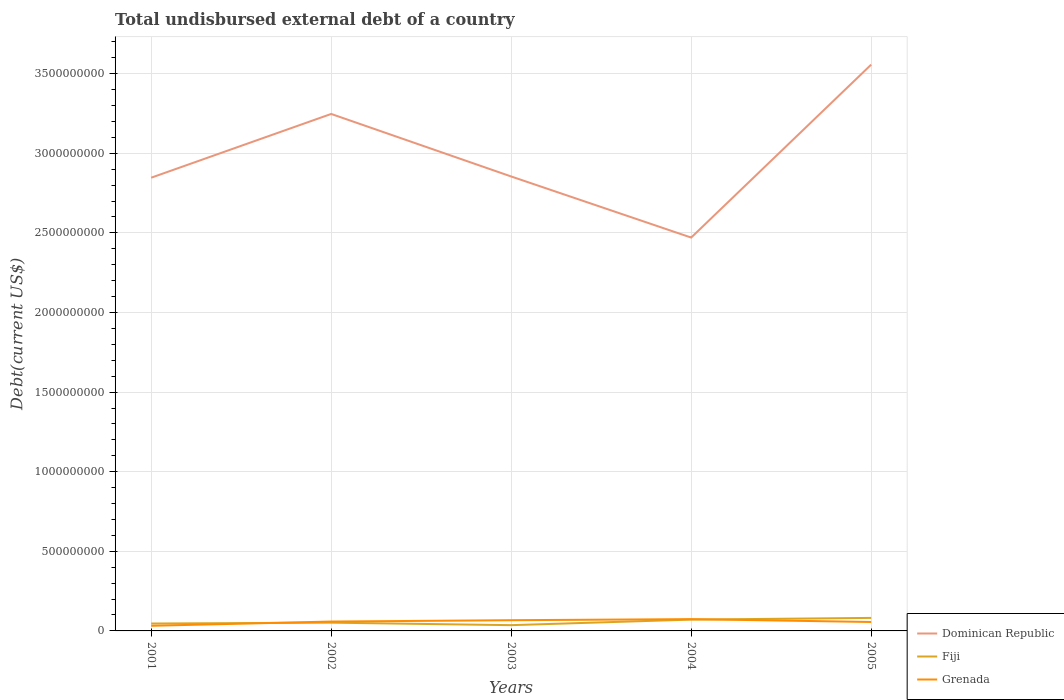Does the line corresponding to Grenada intersect with the line corresponding to Dominican Republic?
Your answer should be very brief. No. Is the number of lines equal to the number of legend labels?
Keep it short and to the point. Yes. Across all years, what is the maximum total undisbursed external debt in Dominican Republic?
Your response must be concise. 2.47e+09. What is the total total undisbursed external debt in Grenada in the graph?
Your answer should be very brief. -6.70e+06. What is the difference between the highest and the second highest total undisbursed external debt in Fiji?
Keep it short and to the point. 4.55e+07. What is the difference between the highest and the lowest total undisbursed external debt in Fiji?
Ensure brevity in your answer.  2. Is the total undisbursed external debt in Grenada strictly greater than the total undisbursed external debt in Fiji over the years?
Offer a very short reply. No. How many lines are there?
Ensure brevity in your answer.  3. Does the graph contain grids?
Provide a succinct answer. Yes. Where does the legend appear in the graph?
Your answer should be compact. Bottom right. What is the title of the graph?
Your response must be concise. Total undisbursed external debt of a country. What is the label or title of the X-axis?
Offer a very short reply. Years. What is the label or title of the Y-axis?
Offer a very short reply. Debt(current US$). What is the Debt(current US$) of Dominican Republic in 2001?
Provide a short and direct response. 2.85e+09. What is the Debt(current US$) of Fiji in 2001?
Offer a terse response. 4.64e+07. What is the Debt(current US$) in Grenada in 2001?
Your answer should be very brief. 3.23e+07. What is the Debt(current US$) in Dominican Republic in 2002?
Your response must be concise. 3.25e+09. What is the Debt(current US$) in Fiji in 2002?
Provide a succinct answer. 5.19e+07. What is the Debt(current US$) of Grenada in 2002?
Your answer should be very brief. 5.88e+07. What is the Debt(current US$) in Dominican Republic in 2003?
Your answer should be very brief. 2.85e+09. What is the Debt(current US$) in Fiji in 2003?
Provide a short and direct response. 3.62e+07. What is the Debt(current US$) in Grenada in 2003?
Your response must be concise. 6.73e+07. What is the Debt(current US$) in Dominican Republic in 2004?
Ensure brevity in your answer.  2.47e+09. What is the Debt(current US$) of Fiji in 2004?
Provide a succinct answer. 7.10e+07. What is the Debt(current US$) in Grenada in 2004?
Offer a very short reply. 7.40e+07. What is the Debt(current US$) of Dominican Republic in 2005?
Make the answer very short. 3.56e+09. What is the Debt(current US$) of Fiji in 2005?
Your answer should be compact. 8.17e+07. What is the Debt(current US$) of Grenada in 2005?
Your answer should be compact. 5.61e+07. Across all years, what is the maximum Debt(current US$) in Dominican Republic?
Provide a short and direct response. 3.56e+09. Across all years, what is the maximum Debt(current US$) in Fiji?
Your answer should be compact. 8.17e+07. Across all years, what is the maximum Debt(current US$) of Grenada?
Provide a succinct answer. 7.40e+07. Across all years, what is the minimum Debt(current US$) in Dominican Republic?
Provide a short and direct response. 2.47e+09. Across all years, what is the minimum Debt(current US$) in Fiji?
Your answer should be very brief. 3.62e+07. Across all years, what is the minimum Debt(current US$) of Grenada?
Your answer should be compact. 3.23e+07. What is the total Debt(current US$) in Dominican Republic in the graph?
Provide a succinct answer. 1.50e+1. What is the total Debt(current US$) in Fiji in the graph?
Offer a terse response. 2.87e+08. What is the total Debt(current US$) of Grenada in the graph?
Offer a terse response. 2.88e+08. What is the difference between the Debt(current US$) of Dominican Republic in 2001 and that in 2002?
Offer a very short reply. -4.00e+08. What is the difference between the Debt(current US$) of Fiji in 2001 and that in 2002?
Give a very brief answer. -5.48e+06. What is the difference between the Debt(current US$) of Grenada in 2001 and that in 2002?
Offer a terse response. -2.66e+07. What is the difference between the Debt(current US$) of Dominican Republic in 2001 and that in 2003?
Keep it short and to the point. -7.69e+06. What is the difference between the Debt(current US$) in Fiji in 2001 and that in 2003?
Provide a succinct answer. 1.02e+07. What is the difference between the Debt(current US$) in Grenada in 2001 and that in 2003?
Your answer should be very brief. -3.50e+07. What is the difference between the Debt(current US$) in Dominican Republic in 2001 and that in 2004?
Make the answer very short. 3.76e+08. What is the difference between the Debt(current US$) in Fiji in 2001 and that in 2004?
Your answer should be very brief. -2.46e+07. What is the difference between the Debt(current US$) in Grenada in 2001 and that in 2004?
Make the answer very short. -4.17e+07. What is the difference between the Debt(current US$) in Dominican Republic in 2001 and that in 2005?
Your answer should be compact. -7.10e+08. What is the difference between the Debt(current US$) in Fiji in 2001 and that in 2005?
Keep it short and to the point. -3.53e+07. What is the difference between the Debt(current US$) of Grenada in 2001 and that in 2005?
Make the answer very short. -2.38e+07. What is the difference between the Debt(current US$) in Dominican Republic in 2002 and that in 2003?
Give a very brief answer. 3.93e+08. What is the difference between the Debt(current US$) in Fiji in 2002 and that in 2003?
Make the answer very short. 1.57e+07. What is the difference between the Debt(current US$) of Grenada in 2002 and that in 2003?
Your answer should be very brief. -8.42e+06. What is the difference between the Debt(current US$) of Dominican Republic in 2002 and that in 2004?
Give a very brief answer. 7.76e+08. What is the difference between the Debt(current US$) of Fiji in 2002 and that in 2004?
Your response must be concise. -1.91e+07. What is the difference between the Debt(current US$) in Grenada in 2002 and that in 2004?
Your response must be concise. -1.51e+07. What is the difference between the Debt(current US$) of Dominican Republic in 2002 and that in 2005?
Provide a succinct answer. -3.10e+08. What is the difference between the Debt(current US$) in Fiji in 2002 and that in 2005?
Offer a terse response. -2.98e+07. What is the difference between the Debt(current US$) of Grenada in 2002 and that in 2005?
Keep it short and to the point. 2.76e+06. What is the difference between the Debt(current US$) in Dominican Republic in 2003 and that in 2004?
Offer a very short reply. 3.84e+08. What is the difference between the Debt(current US$) in Fiji in 2003 and that in 2004?
Keep it short and to the point. -3.48e+07. What is the difference between the Debt(current US$) in Grenada in 2003 and that in 2004?
Offer a very short reply. -6.70e+06. What is the difference between the Debt(current US$) of Dominican Republic in 2003 and that in 2005?
Provide a succinct answer. -7.02e+08. What is the difference between the Debt(current US$) of Fiji in 2003 and that in 2005?
Keep it short and to the point. -4.55e+07. What is the difference between the Debt(current US$) of Grenada in 2003 and that in 2005?
Offer a terse response. 1.12e+07. What is the difference between the Debt(current US$) of Dominican Republic in 2004 and that in 2005?
Ensure brevity in your answer.  -1.09e+09. What is the difference between the Debt(current US$) in Fiji in 2004 and that in 2005?
Provide a short and direct response. -1.07e+07. What is the difference between the Debt(current US$) in Grenada in 2004 and that in 2005?
Give a very brief answer. 1.79e+07. What is the difference between the Debt(current US$) of Dominican Republic in 2001 and the Debt(current US$) of Fiji in 2002?
Provide a short and direct response. 2.79e+09. What is the difference between the Debt(current US$) in Dominican Republic in 2001 and the Debt(current US$) in Grenada in 2002?
Keep it short and to the point. 2.79e+09. What is the difference between the Debt(current US$) of Fiji in 2001 and the Debt(current US$) of Grenada in 2002?
Provide a short and direct response. -1.24e+07. What is the difference between the Debt(current US$) in Dominican Republic in 2001 and the Debt(current US$) in Fiji in 2003?
Provide a short and direct response. 2.81e+09. What is the difference between the Debt(current US$) of Dominican Republic in 2001 and the Debt(current US$) of Grenada in 2003?
Make the answer very short. 2.78e+09. What is the difference between the Debt(current US$) of Fiji in 2001 and the Debt(current US$) of Grenada in 2003?
Your response must be concise. -2.08e+07. What is the difference between the Debt(current US$) of Dominican Republic in 2001 and the Debt(current US$) of Fiji in 2004?
Your answer should be very brief. 2.78e+09. What is the difference between the Debt(current US$) of Dominican Republic in 2001 and the Debt(current US$) of Grenada in 2004?
Offer a very short reply. 2.77e+09. What is the difference between the Debt(current US$) in Fiji in 2001 and the Debt(current US$) in Grenada in 2004?
Keep it short and to the point. -2.75e+07. What is the difference between the Debt(current US$) in Dominican Republic in 2001 and the Debt(current US$) in Fiji in 2005?
Keep it short and to the point. 2.76e+09. What is the difference between the Debt(current US$) in Dominican Republic in 2001 and the Debt(current US$) in Grenada in 2005?
Your answer should be compact. 2.79e+09. What is the difference between the Debt(current US$) in Fiji in 2001 and the Debt(current US$) in Grenada in 2005?
Make the answer very short. -9.67e+06. What is the difference between the Debt(current US$) of Dominican Republic in 2002 and the Debt(current US$) of Fiji in 2003?
Ensure brevity in your answer.  3.21e+09. What is the difference between the Debt(current US$) in Dominican Republic in 2002 and the Debt(current US$) in Grenada in 2003?
Your answer should be very brief. 3.18e+09. What is the difference between the Debt(current US$) in Fiji in 2002 and the Debt(current US$) in Grenada in 2003?
Keep it short and to the point. -1.54e+07. What is the difference between the Debt(current US$) of Dominican Republic in 2002 and the Debt(current US$) of Fiji in 2004?
Offer a very short reply. 3.18e+09. What is the difference between the Debt(current US$) in Dominican Republic in 2002 and the Debt(current US$) in Grenada in 2004?
Give a very brief answer. 3.17e+09. What is the difference between the Debt(current US$) in Fiji in 2002 and the Debt(current US$) in Grenada in 2004?
Give a very brief answer. -2.21e+07. What is the difference between the Debt(current US$) in Dominican Republic in 2002 and the Debt(current US$) in Fiji in 2005?
Provide a short and direct response. 3.17e+09. What is the difference between the Debt(current US$) in Dominican Republic in 2002 and the Debt(current US$) in Grenada in 2005?
Provide a short and direct response. 3.19e+09. What is the difference between the Debt(current US$) of Fiji in 2002 and the Debt(current US$) of Grenada in 2005?
Keep it short and to the point. -4.19e+06. What is the difference between the Debt(current US$) in Dominican Republic in 2003 and the Debt(current US$) in Fiji in 2004?
Ensure brevity in your answer.  2.78e+09. What is the difference between the Debt(current US$) in Dominican Republic in 2003 and the Debt(current US$) in Grenada in 2004?
Your answer should be very brief. 2.78e+09. What is the difference between the Debt(current US$) in Fiji in 2003 and the Debt(current US$) in Grenada in 2004?
Your answer should be very brief. -3.78e+07. What is the difference between the Debt(current US$) in Dominican Republic in 2003 and the Debt(current US$) in Fiji in 2005?
Your response must be concise. 2.77e+09. What is the difference between the Debt(current US$) in Dominican Republic in 2003 and the Debt(current US$) in Grenada in 2005?
Make the answer very short. 2.80e+09. What is the difference between the Debt(current US$) in Fiji in 2003 and the Debt(current US$) in Grenada in 2005?
Your answer should be compact. -1.99e+07. What is the difference between the Debt(current US$) in Dominican Republic in 2004 and the Debt(current US$) in Fiji in 2005?
Your answer should be compact. 2.39e+09. What is the difference between the Debt(current US$) in Dominican Republic in 2004 and the Debt(current US$) in Grenada in 2005?
Provide a succinct answer. 2.41e+09. What is the difference between the Debt(current US$) of Fiji in 2004 and the Debt(current US$) of Grenada in 2005?
Provide a succinct answer. 1.49e+07. What is the average Debt(current US$) of Dominican Republic per year?
Your response must be concise. 2.99e+09. What is the average Debt(current US$) in Fiji per year?
Your response must be concise. 5.75e+07. What is the average Debt(current US$) of Grenada per year?
Give a very brief answer. 5.77e+07. In the year 2001, what is the difference between the Debt(current US$) in Dominican Republic and Debt(current US$) in Fiji?
Make the answer very short. 2.80e+09. In the year 2001, what is the difference between the Debt(current US$) in Dominican Republic and Debt(current US$) in Grenada?
Provide a short and direct response. 2.81e+09. In the year 2001, what is the difference between the Debt(current US$) of Fiji and Debt(current US$) of Grenada?
Ensure brevity in your answer.  1.41e+07. In the year 2002, what is the difference between the Debt(current US$) of Dominican Republic and Debt(current US$) of Fiji?
Keep it short and to the point. 3.19e+09. In the year 2002, what is the difference between the Debt(current US$) in Dominican Republic and Debt(current US$) in Grenada?
Offer a terse response. 3.19e+09. In the year 2002, what is the difference between the Debt(current US$) of Fiji and Debt(current US$) of Grenada?
Provide a succinct answer. -6.95e+06. In the year 2003, what is the difference between the Debt(current US$) in Dominican Republic and Debt(current US$) in Fiji?
Provide a succinct answer. 2.82e+09. In the year 2003, what is the difference between the Debt(current US$) of Dominican Republic and Debt(current US$) of Grenada?
Your response must be concise. 2.79e+09. In the year 2003, what is the difference between the Debt(current US$) of Fiji and Debt(current US$) of Grenada?
Offer a very short reply. -3.11e+07. In the year 2004, what is the difference between the Debt(current US$) of Dominican Republic and Debt(current US$) of Fiji?
Your answer should be very brief. 2.40e+09. In the year 2004, what is the difference between the Debt(current US$) of Dominican Republic and Debt(current US$) of Grenada?
Offer a terse response. 2.40e+09. In the year 2004, what is the difference between the Debt(current US$) of Fiji and Debt(current US$) of Grenada?
Make the answer very short. -2.94e+06. In the year 2005, what is the difference between the Debt(current US$) of Dominican Republic and Debt(current US$) of Fiji?
Ensure brevity in your answer.  3.47e+09. In the year 2005, what is the difference between the Debt(current US$) of Dominican Republic and Debt(current US$) of Grenada?
Keep it short and to the point. 3.50e+09. In the year 2005, what is the difference between the Debt(current US$) in Fiji and Debt(current US$) in Grenada?
Your response must be concise. 2.56e+07. What is the ratio of the Debt(current US$) in Dominican Republic in 2001 to that in 2002?
Make the answer very short. 0.88. What is the ratio of the Debt(current US$) of Fiji in 2001 to that in 2002?
Make the answer very short. 0.89. What is the ratio of the Debt(current US$) in Grenada in 2001 to that in 2002?
Provide a succinct answer. 0.55. What is the ratio of the Debt(current US$) of Dominican Republic in 2001 to that in 2003?
Keep it short and to the point. 1. What is the ratio of the Debt(current US$) of Fiji in 2001 to that in 2003?
Make the answer very short. 1.28. What is the ratio of the Debt(current US$) in Grenada in 2001 to that in 2003?
Ensure brevity in your answer.  0.48. What is the ratio of the Debt(current US$) in Dominican Republic in 2001 to that in 2004?
Offer a terse response. 1.15. What is the ratio of the Debt(current US$) in Fiji in 2001 to that in 2004?
Make the answer very short. 0.65. What is the ratio of the Debt(current US$) in Grenada in 2001 to that in 2004?
Your answer should be compact. 0.44. What is the ratio of the Debt(current US$) of Dominican Republic in 2001 to that in 2005?
Provide a succinct answer. 0.8. What is the ratio of the Debt(current US$) of Fiji in 2001 to that in 2005?
Give a very brief answer. 0.57. What is the ratio of the Debt(current US$) of Grenada in 2001 to that in 2005?
Offer a terse response. 0.58. What is the ratio of the Debt(current US$) of Dominican Republic in 2002 to that in 2003?
Provide a succinct answer. 1.14. What is the ratio of the Debt(current US$) in Fiji in 2002 to that in 2003?
Your response must be concise. 1.43. What is the ratio of the Debt(current US$) of Grenada in 2002 to that in 2003?
Provide a short and direct response. 0.87. What is the ratio of the Debt(current US$) of Dominican Republic in 2002 to that in 2004?
Your answer should be very brief. 1.31. What is the ratio of the Debt(current US$) in Fiji in 2002 to that in 2004?
Keep it short and to the point. 0.73. What is the ratio of the Debt(current US$) in Grenada in 2002 to that in 2004?
Your answer should be compact. 0.8. What is the ratio of the Debt(current US$) of Dominican Republic in 2002 to that in 2005?
Offer a terse response. 0.91. What is the ratio of the Debt(current US$) of Fiji in 2002 to that in 2005?
Make the answer very short. 0.64. What is the ratio of the Debt(current US$) in Grenada in 2002 to that in 2005?
Ensure brevity in your answer.  1.05. What is the ratio of the Debt(current US$) in Dominican Republic in 2003 to that in 2004?
Offer a very short reply. 1.16. What is the ratio of the Debt(current US$) in Fiji in 2003 to that in 2004?
Ensure brevity in your answer.  0.51. What is the ratio of the Debt(current US$) of Grenada in 2003 to that in 2004?
Offer a very short reply. 0.91. What is the ratio of the Debt(current US$) in Dominican Republic in 2003 to that in 2005?
Provide a succinct answer. 0.8. What is the ratio of the Debt(current US$) of Fiji in 2003 to that in 2005?
Provide a succinct answer. 0.44. What is the ratio of the Debt(current US$) in Grenada in 2003 to that in 2005?
Give a very brief answer. 1.2. What is the ratio of the Debt(current US$) of Dominican Republic in 2004 to that in 2005?
Your answer should be very brief. 0.69. What is the ratio of the Debt(current US$) in Fiji in 2004 to that in 2005?
Provide a succinct answer. 0.87. What is the ratio of the Debt(current US$) of Grenada in 2004 to that in 2005?
Provide a succinct answer. 1.32. What is the difference between the highest and the second highest Debt(current US$) of Dominican Republic?
Your response must be concise. 3.10e+08. What is the difference between the highest and the second highest Debt(current US$) of Fiji?
Offer a terse response. 1.07e+07. What is the difference between the highest and the second highest Debt(current US$) of Grenada?
Offer a very short reply. 6.70e+06. What is the difference between the highest and the lowest Debt(current US$) of Dominican Republic?
Your answer should be compact. 1.09e+09. What is the difference between the highest and the lowest Debt(current US$) of Fiji?
Keep it short and to the point. 4.55e+07. What is the difference between the highest and the lowest Debt(current US$) of Grenada?
Offer a very short reply. 4.17e+07. 